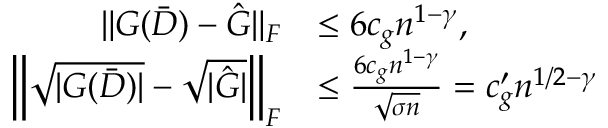Convert formula to latex. <formula><loc_0><loc_0><loc_500><loc_500>\begin{array} { r l } { \| G ( \bar { D } ) - \hat { G } \| _ { F } } & { \leq 6 c _ { g } n ^ { 1 - \gamma } , } \\ { \left \| \sqrt { | G ( \bar { D } ) | } - \sqrt { | \hat { G } | } \right \| _ { F } } & { \leq \frac { 6 c _ { g } n ^ { 1 - \gamma } } { \sqrt { \sigma n } } = c _ { g } ^ { \prime } n ^ { 1 / 2 - \gamma } } \end{array}</formula> 